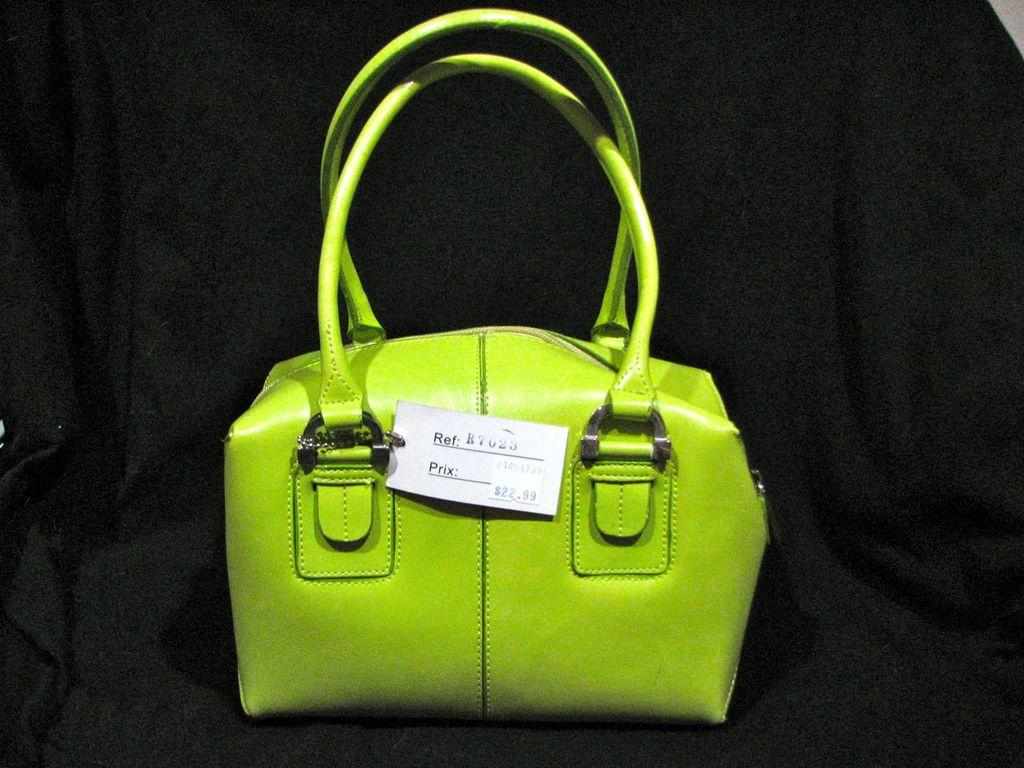What type of bag is visible in the image? There is a green bag in the image. Can you describe any additional features of the green bag? The green bag has a price tag. What can be seen in the background of the image? There is a black cloth in the background of the image. What is the opinion of the doll about the green bag in the image? There is no doll present in the image, so it is not possible to determine its opinion about the green bag. 